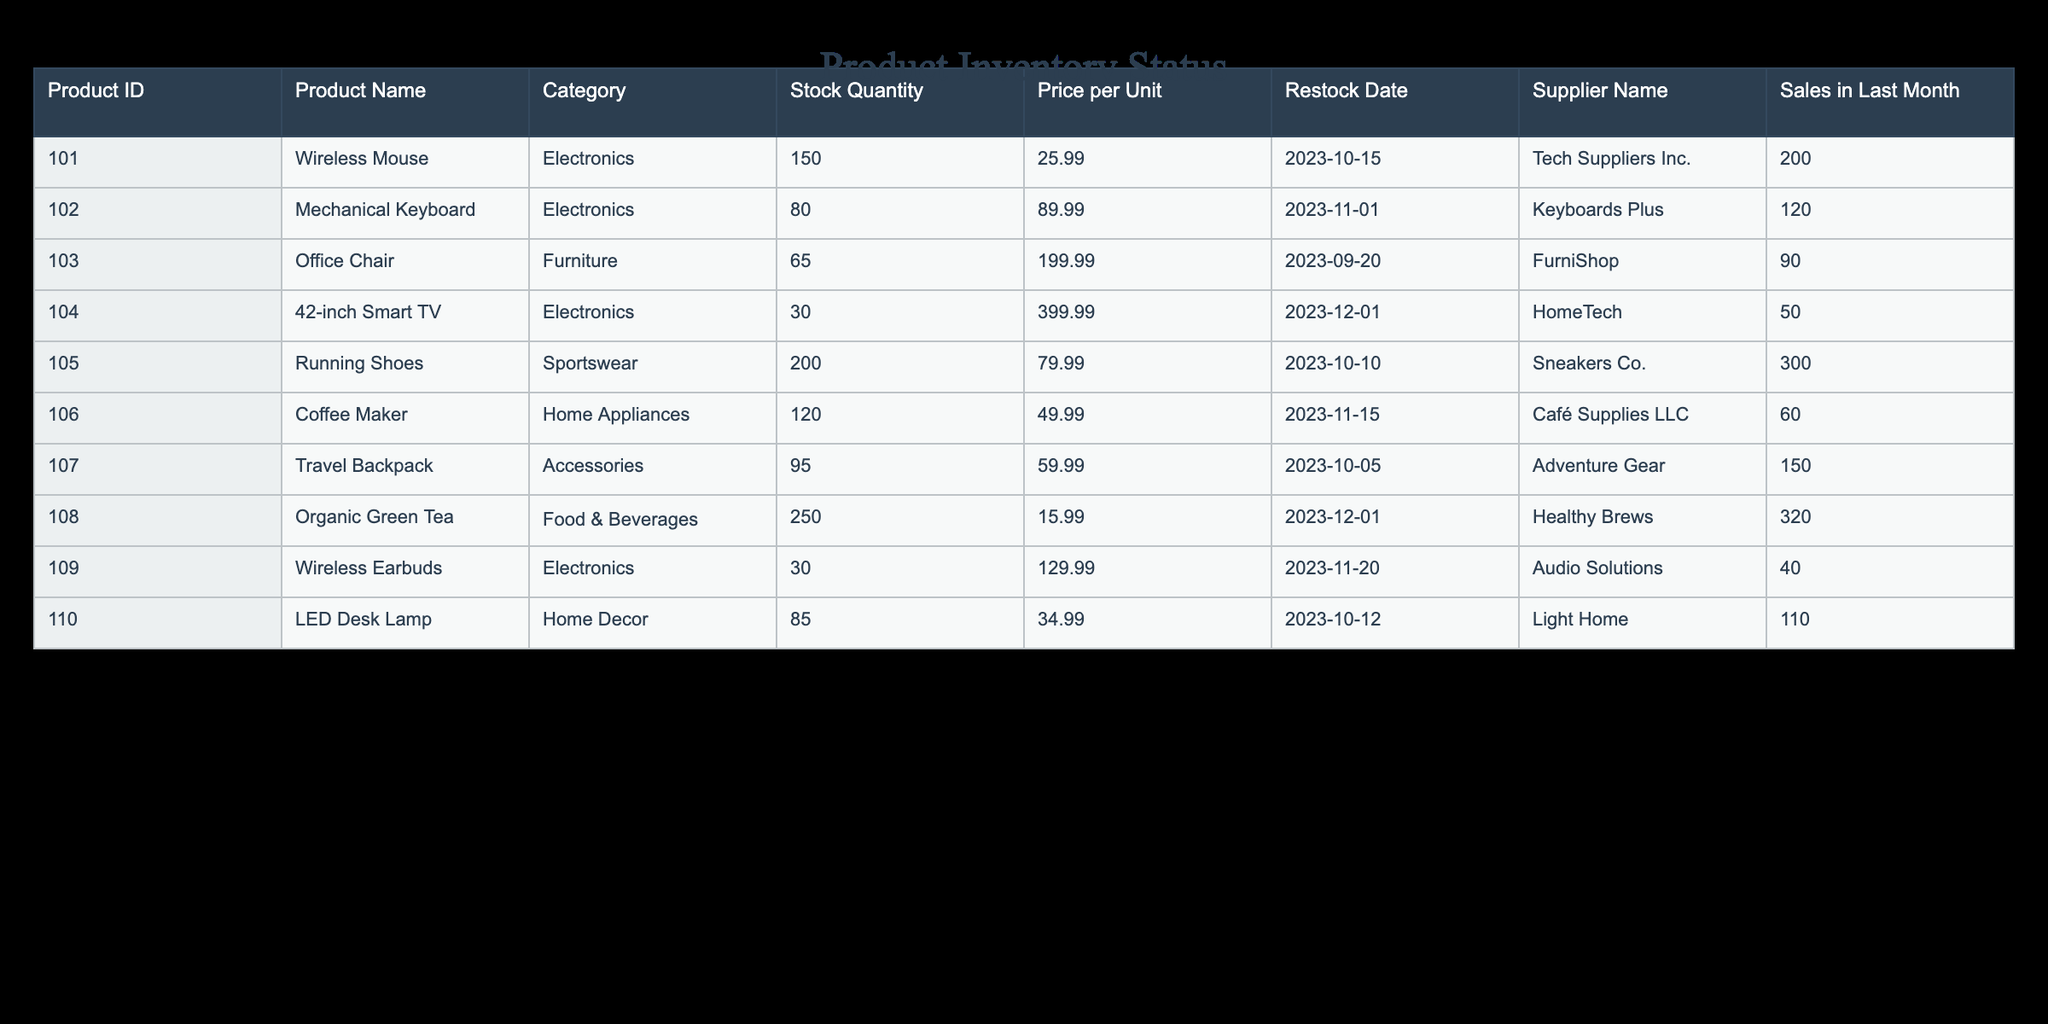What is the stock quantity of the 42-inch Smart TV? The stock quantity is listed under the "Stock Quantity" column for the product "42-inch Smart TV," which is found in the row corresponding to Product ID 104. It shows a stock quantity of 30.
Answer: 30 Which product has the highest price per unit? By reviewing the "Price per Unit" column, the product with the highest price is the "Office Chair," which is priced at 199.99. This is determined by comparing prices across all products.
Answer: 199.99 Is the stock quantity of the Wireless Earbuds more than that of the Mechanical Keyboard? The stock quantity for the Wireless Earbuds is 30, while for the Mechanical Keyboard, it is 80. Since 30 is not greater than 80, the answer is no.
Answer: No What is the total stock quantity of all Electronics products? The stock quantities for Electronics products are as follows: Wireless Mouse (150), Mechanical Keyboard (80), 42-inch Smart TV (30), and Wireless Earbuds (30). Summing these gives 150 + 80 + 30 + 30 = 290.
Answer: 290 What is the average stock quantity of all products available? To find the average stock quantity, we first sum the stock quantities: 150 (Wireless Mouse) + 80 (Mechanical Keyboard) + 65 (Office Chair) + 30 (Smart TV) + 200 (Running Shoes) + 120 (Coffee Maker) + 95 (Travel Backpack) + 250 (Organic Green Tea) + 30 (Wireless Earbuds) + 85 (LED Desk Lamp) = 1,105. There are 10 products in total, so the average is 1,105 / 10 = 110.5.
Answer: 110.5 Which supplier has the most number of products listed in the table? By reviewing the "Supplier Name" column, we see that "Electronics" products from "Tech Suppliers Inc." (1 product), "Keyboards Plus" (1 product), and others, but no supplier has more than one product listed. Hence, all suppliers are tied with one product each.
Answer: No supplier has the most; all have one product 